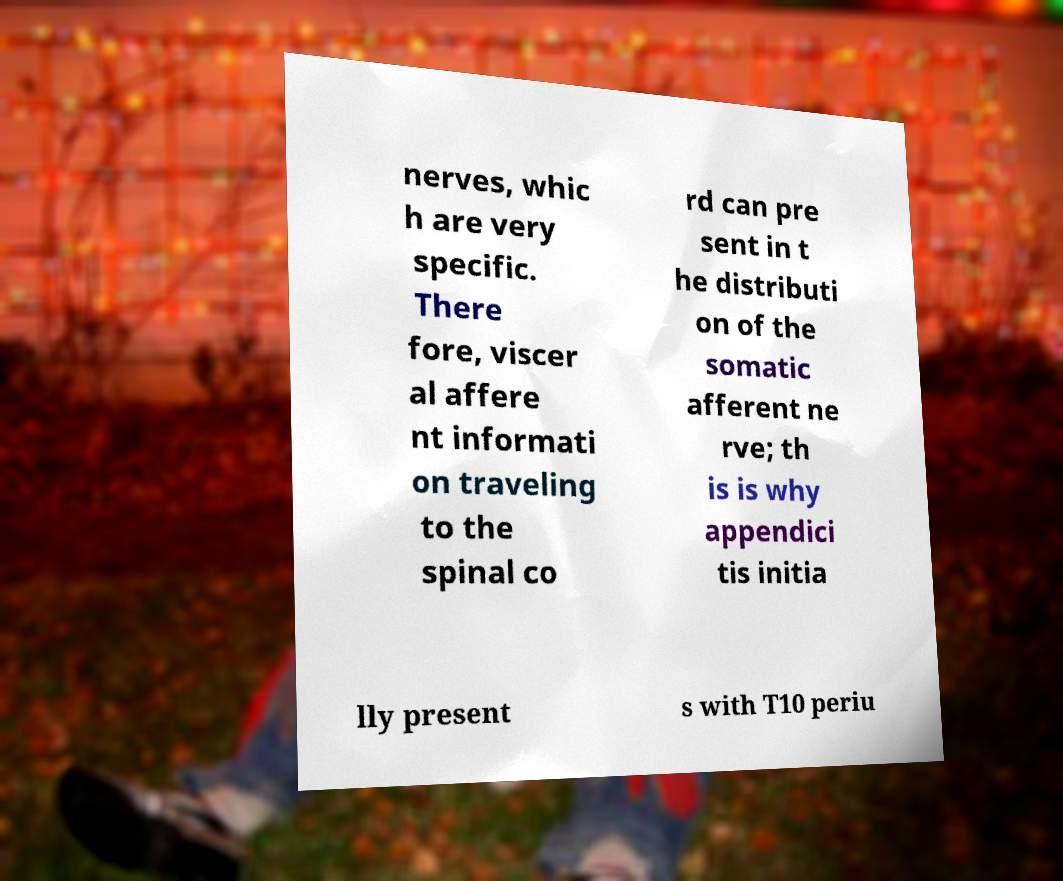There's text embedded in this image that I need extracted. Can you transcribe it verbatim? nerves, whic h are very specific. There fore, viscer al affere nt informati on traveling to the spinal co rd can pre sent in t he distributi on of the somatic afferent ne rve; th is is why appendici tis initia lly present s with T10 periu 